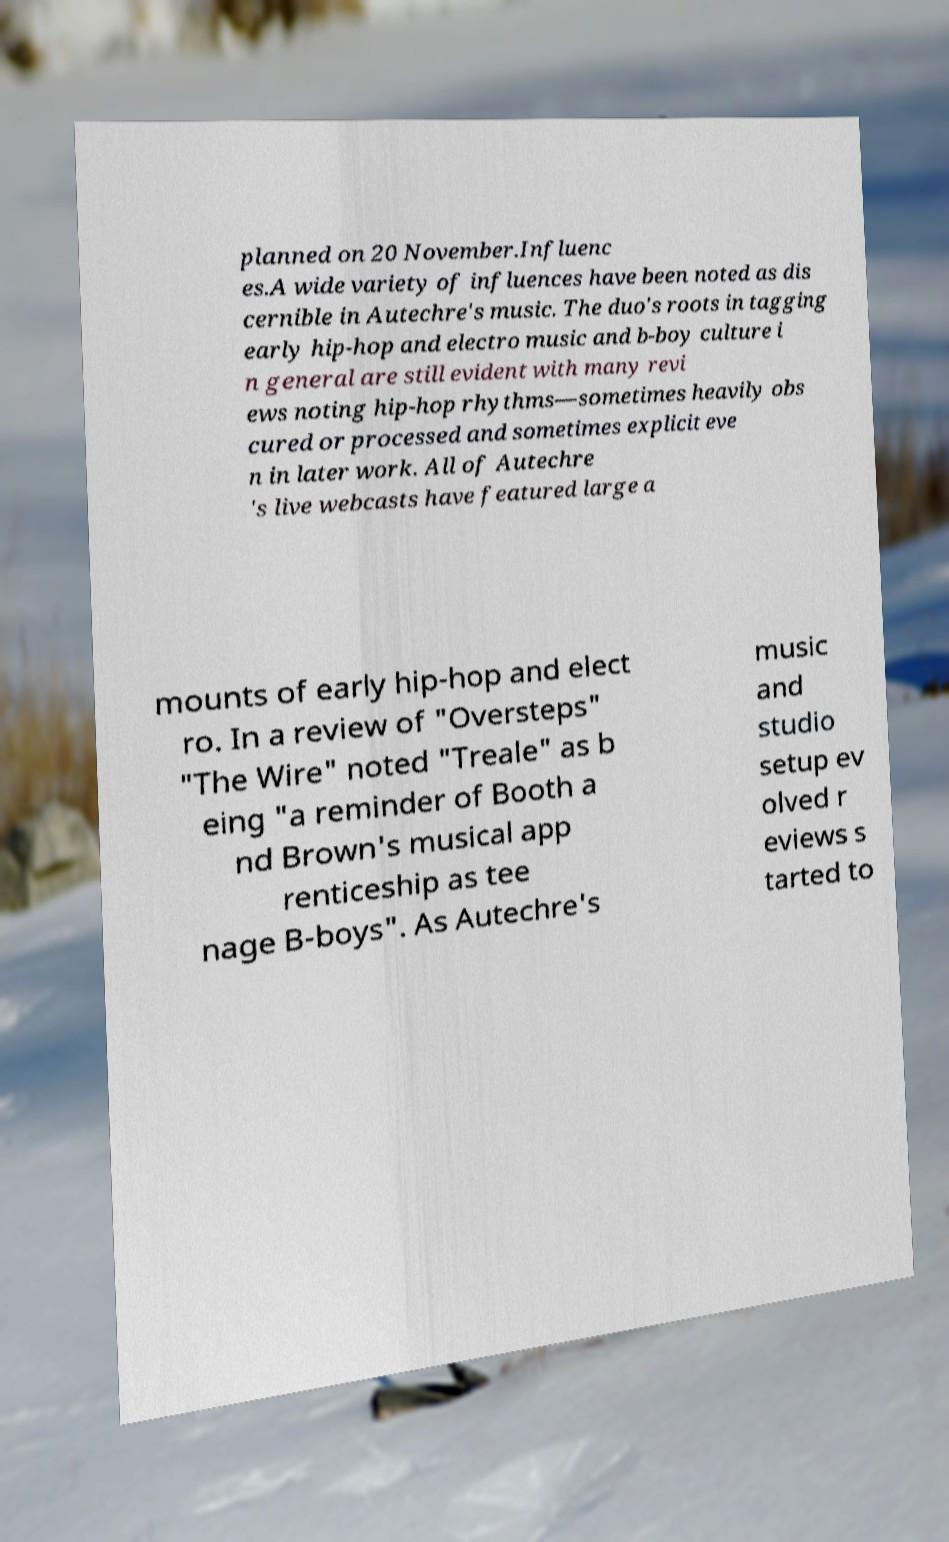There's text embedded in this image that I need extracted. Can you transcribe it verbatim? planned on 20 November.Influenc es.A wide variety of influences have been noted as dis cernible in Autechre's music. The duo's roots in tagging early hip-hop and electro music and b-boy culture i n general are still evident with many revi ews noting hip-hop rhythms—sometimes heavily obs cured or processed and sometimes explicit eve n in later work. All of Autechre 's live webcasts have featured large a mounts of early hip-hop and elect ro. In a review of "Oversteps" "The Wire" noted "Treale" as b eing "a reminder of Booth a nd Brown's musical app renticeship as tee nage B-boys". As Autechre's music and studio setup ev olved r eviews s tarted to 